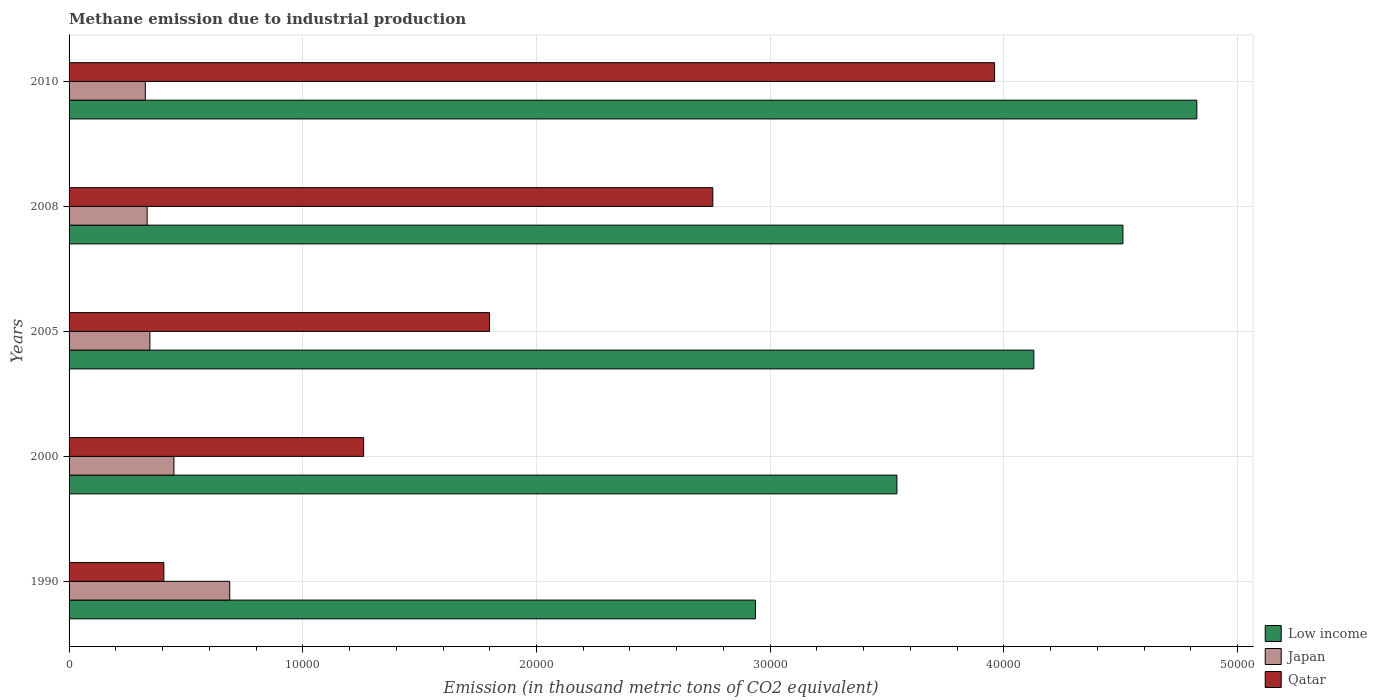Are the number of bars on each tick of the Y-axis equal?
Provide a succinct answer. Yes. How many bars are there on the 4th tick from the bottom?
Give a very brief answer. 3. What is the amount of methane emitted in Qatar in 2008?
Keep it short and to the point. 2.75e+04. Across all years, what is the maximum amount of methane emitted in Japan?
Give a very brief answer. 6873.6. Across all years, what is the minimum amount of methane emitted in Qatar?
Your response must be concise. 4055.8. What is the total amount of methane emitted in Low income in the graph?
Offer a very short reply. 1.99e+05. What is the difference between the amount of methane emitted in Low income in 1990 and that in 2008?
Give a very brief answer. -1.57e+04. What is the difference between the amount of methane emitted in Japan in 1990 and the amount of methane emitted in Qatar in 2008?
Give a very brief answer. -2.07e+04. What is the average amount of methane emitted in Low income per year?
Ensure brevity in your answer.  3.99e+04. In the year 1990, what is the difference between the amount of methane emitted in Qatar and amount of methane emitted in Japan?
Make the answer very short. -2817.8. In how many years, is the amount of methane emitted in Low income greater than 30000 thousand metric tons?
Offer a terse response. 4. What is the ratio of the amount of methane emitted in Low income in 1990 to that in 2008?
Your answer should be compact. 0.65. Is the amount of methane emitted in Qatar in 1990 less than that in 2005?
Offer a very short reply. Yes. What is the difference between the highest and the second highest amount of methane emitted in Qatar?
Your answer should be compact. 1.21e+04. What is the difference between the highest and the lowest amount of methane emitted in Qatar?
Your response must be concise. 3.55e+04. What does the 2nd bar from the top in 1990 represents?
Make the answer very short. Japan. What does the 3rd bar from the bottom in 2000 represents?
Your answer should be compact. Qatar. How many bars are there?
Offer a very short reply. 15. Are all the bars in the graph horizontal?
Your response must be concise. Yes. How many years are there in the graph?
Make the answer very short. 5. Does the graph contain any zero values?
Provide a short and direct response. No. Does the graph contain grids?
Give a very brief answer. Yes. How many legend labels are there?
Provide a succinct answer. 3. What is the title of the graph?
Make the answer very short. Methane emission due to industrial production. What is the label or title of the X-axis?
Provide a succinct answer. Emission (in thousand metric tons of CO2 equivalent). What is the label or title of the Y-axis?
Give a very brief answer. Years. What is the Emission (in thousand metric tons of CO2 equivalent) in Low income in 1990?
Provide a succinct answer. 2.94e+04. What is the Emission (in thousand metric tons of CO2 equivalent) of Japan in 1990?
Keep it short and to the point. 6873.6. What is the Emission (in thousand metric tons of CO2 equivalent) of Qatar in 1990?
Offer a very short reply. 4055.8. What is the Emission (in thousand metric tons of CO2 equivalent) in Low income in 2000?
Give a very brief answer. 3.54e+04. What is the Emission (in thousand metric tons of CO2 equivalent) of Japan in 2000?
Your answer should be very brief. 4486.9. What is the Emission (in thousand metric tons of CO2 equivalent) of Qatar in 2000?
Offer a terse response. 1.26e+04. What is the Emission (in thousand metric tons of CO2 equivalent) in Low income in 2005?
Your answer should be very brief. 4.13e+04. What is the Emission (in thousand metric tons of CO2 equivalent) in Japan in 2005?
Make the answer very short. 3458.3. What is the Emission (in thousand metric tons of CO2 equivalent) in Qatar in 2005?
Provide a short and direct response. 1.80e+04. What is the Emission (in thousand metric tons of CO2 equivalent) of Low income in 2008?
Offer a very short reply. 4.51e+04. What is the Emission (in thousand metric tons of CO2 equivalent) in Japan in 2008?
Keep it short and to the point. 3341. What is the Emission (in thousand metric tons of CO2 equivalent) of Qatar in 2008?
Offer a terse response. 2.75e+04. What is the Emission (in thousand metric tons of CO2 equivalent) of Low income in 2010?
Offer a terse response. 4.83e+04. What is the Emission (in thousand metric tons of CO2 equivalent) in Japan in 2010?
Offer a terse response. 3262. What is the Emission (in thousand metric tons of CO2 equivalent) of Qatar in 2010?
Provide a succinct answer. 3.96e+04. Across all years, what is the maximum Emission (in thousand metric tons of CO2 equivalent) of Low income?
Ensure brevity in your answer.  4.83e+04. Across all years, what is the maximum Emission (in thousand metric tons of CO2 equivalent) of Japan?
Your answer should be compact. 6873.6. Across all years, what is the maximum Emission (in thousand metric tons of CO2 equivalent) of Qatar?
Ensure brevity in your answer.  3.96e+04. Across all years, what is the minimum Emission (in thousand metric tons of CO2 equivalent) of Low income?
Provide a succinct answer. 2.94e+04. Across all years, what is the minimum Emission (in thousand metric tons of CO2 equivalent) in Japan?
Your answer should be very brief. 3262. Across all years, what is the minimum Emission (in thousand metric tons of CO2 equivalent) in Qatar?
Your response must be concise. 4055.8. What is the total Emission (in thousand metric tons of CO2 equivalent) in Low income in the graph?
Offer a very short reply. 1.99e+05. What is the total Emission (in thousand metric tons of CO2 equivalent) of Japan in the graph?
Your answer should be very brief. 2.14e+04. What is the total Emission (in thousand metric tons of CO2 equivalent) in Qatar in the graph?
Your answer should be very brief. 1.02e+05. What is the difference between the Emission (in thousand metric tons of CO2 equivalent) in Low income in 1990 and that in 2000?
Give a very brief answer. -6052.7. What is the difference between the Emission (in thousand metric tons of CO2 equivalent) of Japan in 1990 and that in 2000?
Your response must be concise. 2386.7. What is the difference between the Emission (in thousand metric tons of CO2 equivalent) in Qatar in 1990 and that in 2000?
Give a very brief answer. -8547.3. What is the difference between the Emission (in thousand metric tons of CO2 equivalent) of Low income in 1990 and that in 2005?
Offer a very short reply. -1.19e+04. What is the difference between the Emission (in thousand metric tons of CO2 equivalent) of Japan in 1990 and that in 2005?
Offer a terse response. 3415.3. What is the difference between the Emission (in thousand metric tons of CO2 equivalent) of Qatar in 1990 and that in 2005?
Ensure brevity in your answer.  -1.39e+04. What is the difference between the Emission (in thousand metric tons of CO2 equivalent) in Low income in 1990 and that in 2008?
Offer a terse response. -1.57e+04. What is the difference between the Emission (in thousand metric tons of CO2 equivalent) of Japan in 1990 and that in 2008?
Make the answer very short. 3532.6. What is the difference between the Emission (in thousand metric tons of CO2 equivalent) in Qatar in 1990 and that in 2008?
Make the answer very short. -2.35e+04. What is the difference between the Emission (in thousand metric tons of CO2 equivalent) of Low income in 1990 and that in 2010?
Offer a terse response. -1.89e+04. What is the difference between the Emission (in thousand metric tons of CO2 equivalent) in Japan in 1990 and that in 2010?
Make the answer very short. 3611.6. What is the difference between the Emission (in thousand metric tons of CO2 equivalent) of Qatar in 1990 and that in 2010?
Your answer should be compact. -3.55e+04. What is the difference between the Emission (in thousand metric tons of CO2 equivalent) in Low income in 2000 and that in 2005?
Keep it short and to the point. -5857.3. What is the difference between the Emission (in thousand metric tons of CO2 equivalent) of Japan in 2000 and that in 2005?
Make the answer very short. 1028.6. What is the difference between the Emission (in thousand metric tons of CO2 equivalent) in Qatar in 2000 and that in 2005?
Give a very brief answer. -5388.1. What is the difference between the Emission (in thousand metric tons of CO2 equivalent) in Low income in 2000 and that in 2008?
Ensure brevity in your answer.  -9669.8. What is the difference between the Emission (in thousand metric tons of CO2 equivalent) in Japan in 2000 and that in 2008?
Your response must be concise. 1145.9. What is the difference between the Emission (in thousand metric tons of CO2 equivalent) of Qatar in 2000 and that in 2008?
Provide a succinct answer. -1.49e+04. What is the difference between the Emission (in thousand metric tons of CO2 equivalent) in Low income in 2000 and that in 2010?
Your response must be concise. -1.28e+04. What is the difference between the Emission (in thousand metric tons of CO2 equivalent) in Japan in 2000 and that in 2010?
Offer a terse response. 1224.9. What is the difference between the Emission (in thousand metric tons of CO2 equivalent) in Qatar in 2000 and that in 2010?
Ensure brevity in your answer.  -2.70e+04. What is the difference between the Emission (in thousand metric tons of CO2 equivalent) in Low income in 2005 and that in 2008?
Ensure brevity in your answer.  -3812.5. What is the difference between the Emission (in thousand metric tons of CO2 equivalent) of Japan in 2005 and that in 2008?
Your response must be concise. 117.3. What is the difference between the Emission (in thousand metric tons of CO2 equivalent) in Qatar in 2005 and that in 2008?
Your answer should be compact. -9553.4. What is the difference between the Emission (in thousand metric tons of CO2 equivalent) of Low income in 2005 and that in 2010?
Your answer should be very brief. -6974.9. What is the difference between the Emission (in thousand metric tons of CO2 equivalent) in Japan in 2005 and that in 2010?
Provide a succinct answer. 196.3. What is the difference between the Emission (in thousand metric tons of CO2 equivalent) in Qatar in 2005 and that in 2010?
Your answer should be compact. -2.16e+04. What is the difference between the Emission (in thousand metric tons of CO2 equivalent) in Low income in 2008 and that in 2010?
Provide a succinct answer. -3162.4. What is the difference between the Emission (in thousand metric tons of CO2 equivalent) of Japan in 2008 and that in 2010?
Your answer should be compact. 79. What is the difference between the Emission (in thousand metric tons of CO2 equivalent) in Qatar in 2008 and that in 2010?
Your response must be concise. -1.21e+04. What is the difference between the Emission (in thousand metric tons of CO2 equivalent) in Low income in 1990 and the Emission (in thousand metric tons of CO2 equivalent) in Japan in 2000?
Your response must be concise. 2.49e+04. What is the difference between the Emission (in thousand metric tons of CO2 equivalent) in Low income in 1990 and the Emission (in thousand metric tons of CO2 equivalent) in Qatar in 2000?
Keep it short and to the point. 1.68e+04. What is the difference between the Emission (in thousand metric tons of CO2 equivalent) in Japan in 1990 and the Emission (in thousand metric tons of CO2 equivalent) in Qatar in 2000?
Ensure brevity in your answer.  -5729.5. What is the difference between the Emission (in thousand metric tons of CO2 equivalent) of Low income in 1990 and the Emission (in thousand metric tons of CO2 equivalent) of Japan in 2005?
Your answer should be very brief. 2.59e+04. What is the difference between the Emission (in thousand metric tons of CO2 equivalent) in Low income in 1990 and the Emission (in thousand metric tons of CO2 equivalent) in Qatar in 2005?
Offer a very short reply. 1.14e+04. What is the difference between the Emission (in thousand metric tons of CO2 equivalent) in Japan in 1990 and the Emission (in thousand metric tons of CO2 equivalent) in Qatar in 2005?
Keep it short and to the point. -1.11e+04. What is the difference between the Emission (in thousand metric tons of CO2 equivalent) of Low income in 1990 and the Emission (in thousand metric tons of CO2 equivalent) of Japan in 2008?
Your answer should be very brief. 2.60e+04. What is the difference between the Emission (in thousand metric tons of CO2 equivalent) of Low income in 1990 and the Emission (in thousand metric tons of CO2 equivalent) of Qatar in 2008?
Provide a short and direct response. 1825.3. What is the difference between the Emission (in thousand metric tons of CO2 equivalent) of Japan in 1990 and the Emission (in thousand metric tons of CO2 equivalent) of Qatar in 2008?
Keep it short and to the point. -2.07e+04. What is the difference between the Emission (in thousand metric tons of CO2 equivalent) of Low income in 1990 and the Emission (in thousand metric tons of CO2 equivalent) of Japan in 2010?
Your answer should be very brief. 2.61e+04. What is the difference between the Emission (in thousand metric tons of CO2 equivalent) in Low income in 1990 and the Emission (in thousand metric tons of CO2 equivalent) in Qatar in 2010?
Offer a very short reply. -1.02e+04. What is the difference between the Emission (in thousand metric tons of CO2 equivalent) in Japan in 1990 and the Emission (in thousand metric tons of CO2 equivalent) in Qatar in 2010?
Make the answer very short. -3.27e+04. What is the difference between the Emission (in thousand metric tons of CO2 equivalent) in Low income in 2000 and the Emission (in thousand metric tons of CO2 equivalent) in Japan in 2005?
Make the answer very short. 3.20e+04. What is the difference between the Emission (in thousand metric tons of CO2 equivalent) of Low income in 2000 and the Emission (in thousand metric tons of CO2 equivalent) of Qatar in 2005?
Offer a terse response. 1.74e+04. What is the difference between the Emission (in thousand metric tons of CO2 equivalent) of Japan in 2000 and the Emission (in thousand metric tons of CO2 equivalent) of Qatar in 2005?
Keep it short and to the point. -1.35e+04. What is the difference between the Emission (in thousand metric tons of CO2 equivalent) in Low income in 2000 and the Emission (in thousand metric tons of CO2 equivalent) in Japan in 2008?
Make the answer very short. 3.21e+04. What is the difference between the Emission (in thousand metric tons of CO2 equivalent) in Low income in 2000 and the Emission (in thousand metric tons of CO2 equivalent) in Qatar in 2008?
Provide a succinct answer. 7878. What is the difference between the Emission (in thousand metric tons of CO2 equivalent) of Japan in 2000 and the Emission (in thousand metric tons of CO2 equivalent) of Qatar in 2008?
Offer a very short reply. -2.31e+04. What is the difference between the Emission (in thousand metric tons of CO2 equivalent) in Low income in 2000 and the Emission (in thousand metric tons of CO2 equivalent) in Japan in 2010?
Keep it short and to the point. 3.22e+04. What is the difference between the Emission (in thousand metric tons of CO2 equivalent) in Low income in 2000 and the Emission (in thousand metric tons of CO2 equivalent) in Qatar in 2010?
Ensure brevity in your answer.  -4177.6. What is the difference between the Emission (in thousand metric tons of CO2 equivalent) in Japan in 2000 and the Emission (in thousand metric tons of CO2 equivalent) in Qatar in 2010?
Keep it short and to the point. -3.51e+04. What is the difference between the Emission (in thousand metric tons of CO2 equivalent) of Low income in 2005 and the Emission (in thousand metric tons of CO2 equivalent) of Japan in 2008?
Give a very brief answer. 3.79e+04. What is the difference between the Emission (in thousand metric tons of CO2 equivalent) in Low income in 2005 and the Emission (in thousand metric tons of CO2 equivalent) in Qatar in 2008?
Make the answer very short. 1.37e+04. What is the difference between the Emission (in thousand metric tons of CO2 equivalent) in Japan in 2005 and the Emission (in thousand metric tons of CO2 equivalent) in Qatar in 2008?
Give a very brief answer. -2.41e+04. What is the difference between the Emission (in thousand metric tons of CO2 equivalent) in Low income in 2005 and the Emission (in thousand metric tons of CO2 equivalent) in Japan in 2010?
Keep it short and to the point. 3.80e+04. What is the difference between the Emission (in thousand metric tons of CO2 equivalent) in Low income in 2005 and the Emission (in thousand metric tons of CO2 equivalent) in Qatar in 2010?
Provide a short and direct response. 1679.7. What is the difference between the Emission (in thousand metric tons of CO2 equivalent) of Japan in 2005 and the Emission (in thousand metric tons of CO2 equivalent) of Qatar in 2010?
Your answer should be compact. -3.61e+04. What is the difference between the Emission (in thousand metric tons of CO2 equivalent) in Low income in 2008 and the Emission (in thousand metric tons of CO2 equivalent) in Japan in 2010?
Offer a terse response. 4.18e+04. What is the difference between the Emission (in thousand metric tons of CO2 equivalent) of Low income in 2008 and the Emission (in thousand metric tons of CO2 equivalent) of Qatar in 2010?
Your response must be concise. 5492.2. What is the difference between the Emission (in thousand metric tons of CO2 equivalent) in Japan in 2008 and the Emission (in thousand metric tons of CO2 equivalent) in Qatar in 2010?
Ensure brevity in your answer.  -3.63e+04. What is the average Emission (in thousand metric tons of CO2 equivalent) in Low income per year?
Keep it short and to the point. 3.99e+04. What is the average Emission (in thousand metric tons of CO2 equivalent) of Japan per year?
Ensure brevity in your answer.  4284.36. What is the average Emission (in thousand metric tons of CO2 equivalent) in Qatar per year?
Keep it short and to the point. 2.04e+04. In the year 1990, what is the difference between the Emission (in thousand metric tons of CO2 equivalent) in Low income and Emission (in thousand metric tons of CO2 equivalent) in Japan?
Keep it short and to the point. 2.25e+04. In the year 1990, what is the difference between the Emission (in thousand metric tons of CO2 equivalent) of Low income and Emission (in thousand metric tons of CO2 equivalent) of Qatar?
Your answer should be very brief. 2.53e+04. In the year 1990, what is the difference between the Emission (in thousand metric tons of CO2 equivalent) of Japan and Emission (in thousand metric tons of CO2 equivalent) of Qatar?
Your response must be concise. 2817.8. In the year 2000, what is the difference between the Emission (in thousand metric tons of CO2 equivalent) of Low income and Emission (in thousand metric tons of CO2 equivalent) of Japan?
Provide a short and direct response. 3.09e+04. In the year 2000, what is the difference between the Emission (in thousand metric tons of CO2 equivalent) in Low income and Emission (in thousand metric tons of CO2 equivalent) in Qatar?
Your answer should be compact. 2.28e+04. In the year 2000, what is the difference between the Emission (in thousand metric tons of CO2 equivalent) in Japan and Emission (in thousand metric tons of CO2 equivalent) in Qatar?
Offer a very short reply. -8116.2. In the year 2005, what is the difference between the Emission (in thousand metric tons of CO2 equivalent) of Low income and Emission (in thousand metric tons of CO2 equivalent) of Japan?
Offer a very short reply. 3.78e+04. In the year 2005, what is the difference between the Emission (in thousand metric tons of CO2 equivalent) of Low income and Emission (in thousand metric tons of CO2 equivalent) of Qatar?
Provide a short and direct response. 2.33e+04. In the year 2005, what is the difference between the Emission (in thousand metric tons of CO2 equivalent) of Japan and Emission (in thousand metric tons of CO2 equivalent) of Qatar?
Keep it short and to the point. -1.45e+04. In the year 2008, what is the difference between the Emission (in thousand metric tons of CO2 equivalent) of Low income and Emission (in thousand metric tons of CO2 equivalent) of Japan?
Give a very brief answer. 4.18e+04. In the year 2008, what is the difference between the Emission (in thousand metric tons of CO2 equivalent) of Low income and Emission (in thousand metric tons of CO2 equivalent) of Qatar?
Provide a short and direct response. 1.75e+04. In the year 2008, what is the difference between the Emission (in thousand metric tons of CO2 equivalent) in Japan and Emission (in thousand metric tons of CO2 equivalent) in Qatar?
Give a very brief answer. -2.42e+04. In the year 2010, what is the difference between the Emission (in thousand metric tons of CO2 equivalent) of Low income and Emission (in thousand metric tons of CO2 equivalent) of Japan?
Give a very brief answer. 4.50e+04. In the year 2010, what is the difference between the Emission (in thousand metric tons of CO2 equivalent) of Low income and Emission (in thousand metric tons of CO2 equivalent) of Qatar?
Offer a terse response. 8654.6. In the year 2010, what is the difference between the Emission (in thousand metric tons of CO2 equivalent) of Japan and Emission (in thousand metric tons of CO2 equivalent) of Qatar?
Provide a succinct answer. -3.63e+04. What is the ratio of the Emission (in thousand metric tons of CO2 equivalent) in Low income in 1990 to that in 2000?
Provide a short and direct response. 0.83. What is the ratio of the Emission (in thousand metric tons of CO2 equivalent) of Japan in 1990 to that in 2000?
Ensure brevity in your answer.  1.53. What is the ratio of the Emission (in thousand metric tons of CO2 equivalent) of Qatar in 1990 to that in 2000?
Ensure brevity in your answer.  0.32. What is the ratio of the Emission (in thousand metric tons of CO2 equivalent) in Low income in 1990 to that in 2005?
Your answer should be very brief. 0.71. What is the ratio of the Emission (in thousand metric tons of CO2 equivalent) in Japan in 1990 to that in 2005?
Provide a short and direct response. 1.99. What is the ratio of the Emission (in thousand metric tons of CO2 equivalent) in Qatar in 1990 to that in 2005?
Your answer should be very brief. 0.23. What is the ratio of the Emission (in thousand metric tons of CO2 equivalent) of Low income in 1990 to that in 2008?
Provide a succinct answer. 0.65. What is the ratio of the Emission (in thousand metric tons of CO2 equivalent) of Japan in 1990 to that in 2008?
Your answer should be compact. 2.06. What is the ratio of the Emission (in thousand metric tons of CO2 equivalent) of Qatar in 1990 to that in 2008?
Provide a short and direct response. 0.15. What is the ratio of the Emission (in thousand metric tons of CO2 equivalent) of Low income in 1990 to that in 2010?
Keep it short and to the point. 0.61. What is the ratio of the Emission (in thousand metric tons of CO2 equivalent) in Japan in 1990 to that in 2010?
Provide a succinct answer. 2.11. What is the ratio of the Emission (in thousand metric tons of CO2 equivalent) of Qatar in 1990 to that in 2010?
Keep it short and to the point. 0.1. What is the ratio of the Emission (in thousand metric tons of CO2 equivalent) in Low income in 2000 to that in 2005?
Provide a short and direct response. 0.86. What is the ratio of the Emission (in thousand metric tons of CO2 equivalent) of Japan in 2000 to that in 2005?
Keep it short and to the point. 1.3. What is the ratio of the Emission (in thousand metric tons of CO2 equivalent) of Qatar in 2000 to that in 2005?
Offer a very short reply. 0.7. What is the ratio of the Emission (in thousand metric tons of CO2 equivalent) in Low income in 2000 to that in 2008?
Your answer should be compact. 0.79. What is the ratio of the Emission (in thousand metric tons of CO2 equivalent) in Japan in 2000 to that in 2008?
Provide a short and direct response. 1.34. What is the ratio of the Emission (in thousand metric tons of CO2 equivalent) in Qatar in 2000 to that in 2008?
Offer a terse response. 0.46. What is the ratio of the Emission (in thousand metric tons of CO2 equivalent) of Low income in 2000 to that in 2010?
Offer a terse response. 0.73. What is the ratio of the Emission (in thousand metric tons of CO2 equivalent) in Japan in 2000 to that in 2010?
Make the answer very short. 1.38. What is the ratio of the Emission (in thousand metric tons of CO2 equivalent) in Qatar in 2000 to that in 2010?
Your answer should be very brief. 0.32. What is the ratio of the Emission (in thousand metric tons of CO2 equivalent) in Low income in 2005 to that in 2008?
Your answer should be very brief. 0.92. What is the ratio of the Emission (in thousand metric tons of CO2 equivalent) in Japan in 2005 to that in 2008?
Ensure brevity in your answer.  1.04. What is the ratio of the Emission (in thousand metric tons of CO2 equivalent) in Qatar in 2005 to that in 2008?
Your answer should be compact. 0.65. What is the ratio of the Emission (in thousand metric tons of CO2 equivalent) of Low income in 2005 to that in 2010?
Keep it short and to the point. 0.86. What is the ratio of the Emission (in thousand metric tons of CO2 equivalent) in Japan in 2005 to that in 2010?
Your answer should be compact. 1.06. What is the ratio of the Emission (in thousand metric tons of CO2 equivalent) of Qatar in 2005 to that in 2010?
Provide a succinct answer. 0.45. What is the ratio of the Emission (in thousand metric tons of CO2 equivalent) in Low income in 2008 to that in 2010?
Provide a short and direct response. 0.93. What is the ratio of the Emission (in thousand metric tons of CO2 equivalent) in Japan in 2008 to that in 2010?
Ensure brevity in your answer.  1.02. What is the ratio of the Emission (in thousand metric tons of CO2 equivalent) in Qatar in 2008 to that in 2010?
Your answer should be compact. 0.7. What is the difference between the highest and the second highest Emission (in thousand metric tons of CO2 equivalent) of Low income?
Make the answer very short. 3162.4. What is the difference between the highest and the second highest Emission (in thousand metric tons of CO2 equivalent) of Japan?
Offer a terse response. 2386.7. What is the difference between the highest and the second highest Emission (in thousand metric tons of CO2 equivalent) in Qatar?
Give a very brief answer. 1.21e+04. What is the difference between the highest and the lowest Emission (in thousand metric tons of CO2 equivalent) in Low income?
Keep it short and to the point. 1.89e+04. What is the difference between the highest and the lowest Emission (in thousand metric tons of CO2 equivalent) in Japan?
Make the answer very short. 3611.6. What is the difference between the highest and the lowest Emission (in thousand metric tons of CO2 equivalent) of Qatar?
Provide a succinct answer. 3.55e+04. 